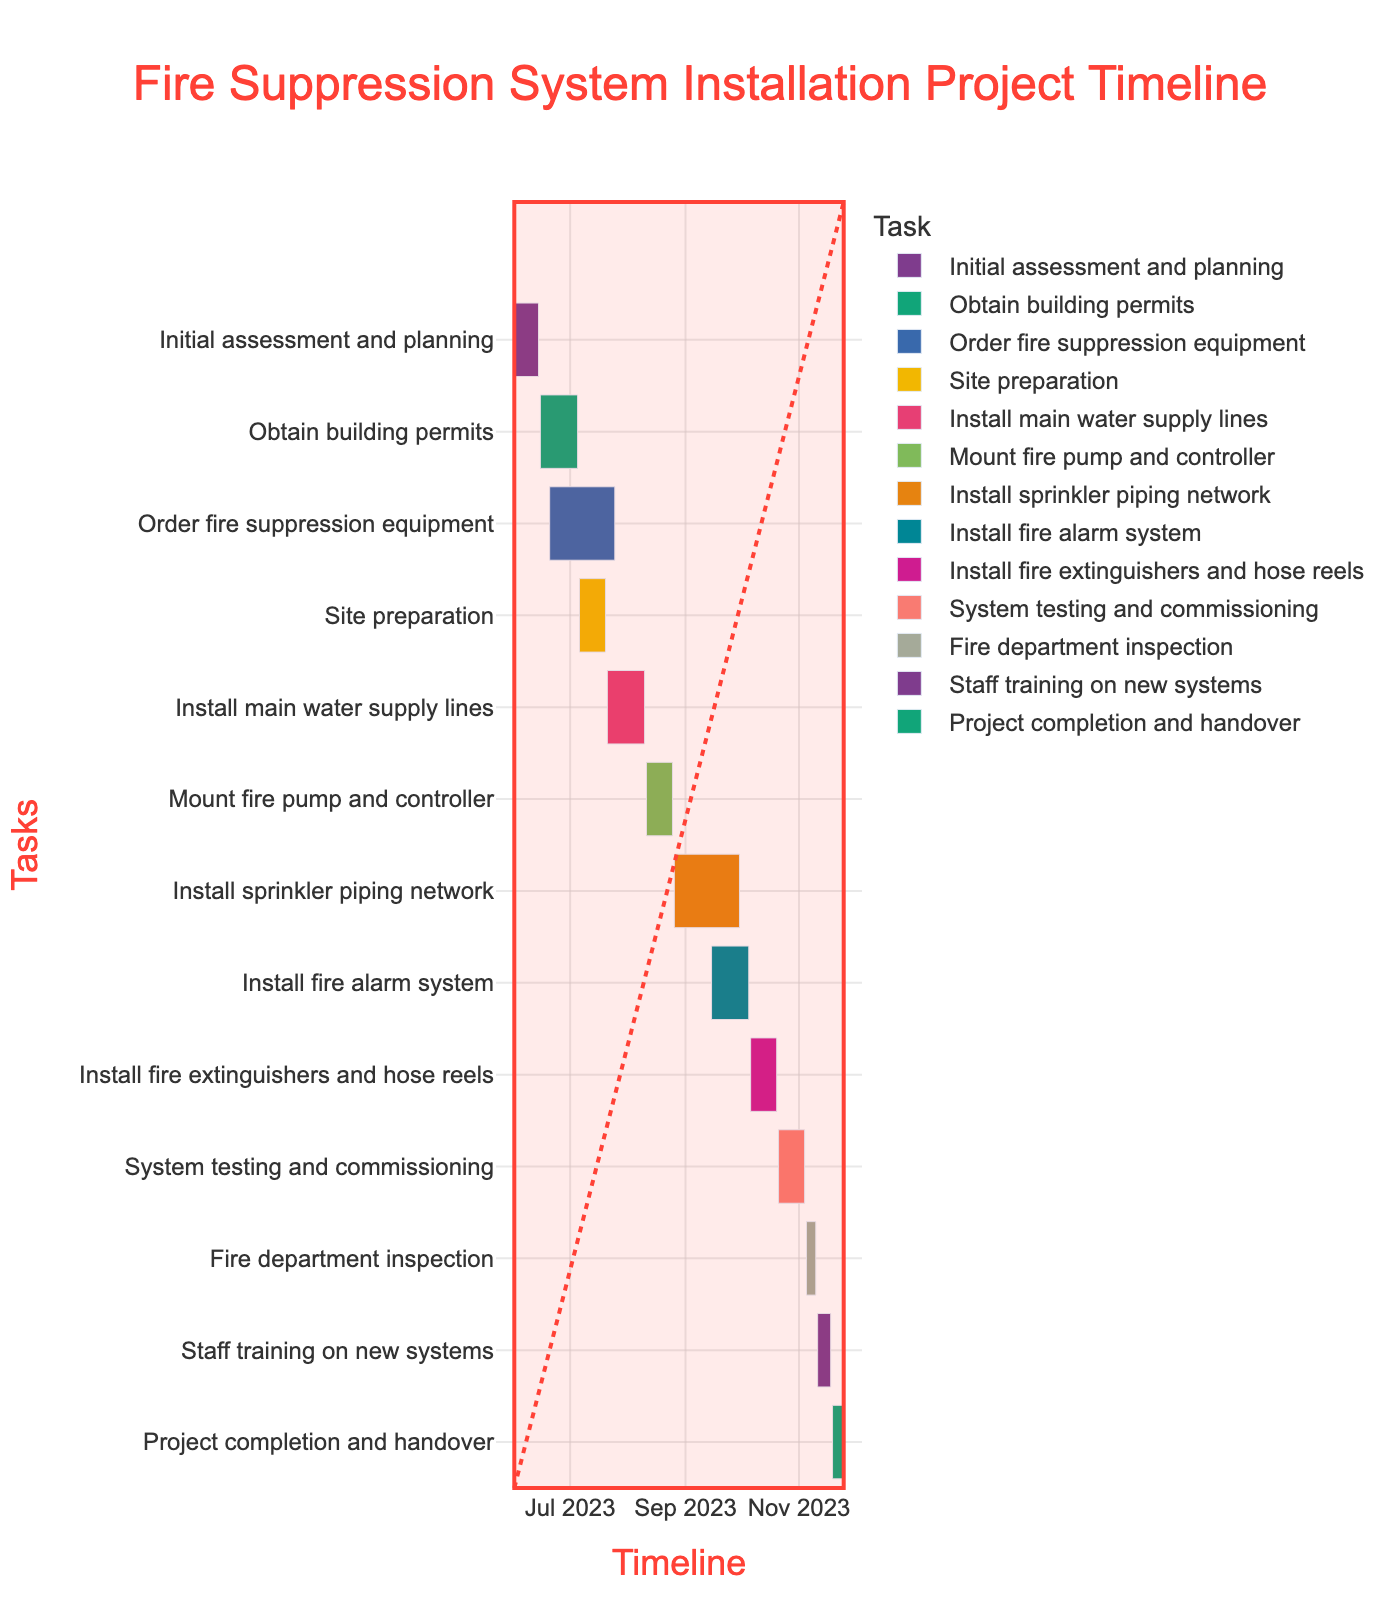What is the duration of the "Order fire suppression equipment" task? The "Order fire suppression equipment" task starts on June 20, 2023, and ends on July 25, 2023. The Gantt chart shows it has a duration of 35 days.
Answer: 35 days Which task takes the longest to complete? By examining all the tasks on the Gantt chart and their respective durations, the "Install sprinkler piping network" task has the longest duration, lasting from August 26, 2023, to September 30, 2023, which is 36 days.
Answer: Install sprinkler piping network How many tasks have a duration of exactly 15 days? By scanning the tasks and their durations, the tasks with exactly 15 days of duration are "Site preparation," "Mount fire pump and controller," "Install fire extinguishers and hose reels," and "System testing and commissioning." There are four tasks.
Answer: 4 When does the "Obtain building permits" task end? By looking at the Gantt chart, we find that the "Obtain building permits" task ends on July 5, 2023.
Answer: July 5, 2023 What tasks are scheduled to be ongoing during the month of September 2023? Checking the Gantt chart for tasks spanning September 2023: "Install sprinkler piping network" (August 26, 2023 - September 30, 2023) and "Install fire alarm system" (September 15, 2023 - October 5, 2023) are ongoing.
Answer: Install sprinkler piping network, Install fire alarm system Which task is scheduled to start right after "Install main water supply lines" completes? "Install main water supply lines" ends on August 10, 2023, and the next task, "Mount fire pump and controller," starts on August 11, 2023.
Answer: Mount fire pump and controller How long is the period between the end of "Site preparation" and the start of "Install main water supply lines"? "Site preparation" ends on July 20, 2023, and "Install main water supply lines" starts on July 21, 2023. The period between these tasks is 1 day.
Answer: 1 day What is the total duration of the project? The project starts with "Initial assessment and planning" on June 1, 2023, and ends with "Project completion and handover" on November 25, 2023. The total duration is from June 1 to November 25.
Answer: 178 days How many tasks are there in total in this project plan? By counting all the listed tasks on the Gantt chart, there are a total of 13 tasks in the project plan.
Answer: 13 